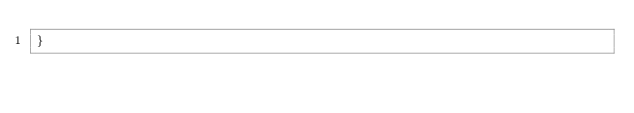<code> <loc_0><loc_0><loc_500><loc_500><_C#_>}
</code> 